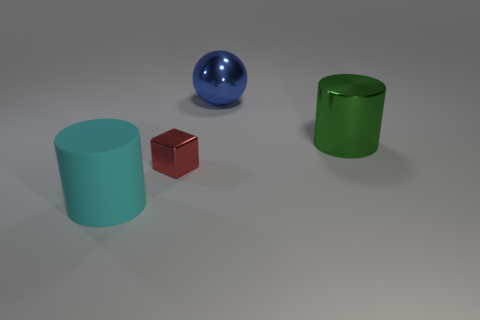Are there any other things that are the same size as the red object?
Provide a succinct answer. No. Is there anything else that has the same material as the cyan object?
Provide a succinct answer. No. There is a cylinder to the left of the metallic cylinder; does it have the same size as the tiny metallic thing?
Your answer should be very brief. No. What number of other objects are there of the same shape as the large blue metal thing?
Provide a succinct answer. 0. Is there a tiny ball that has the same color as the matte thing?
Your answer should be very brief. No. There is a large cyan object; what number of large blue things are behind it?
Ensure brevity in your answer.  1. How many other things are the same size as the cyan rubber cylinder?
Your answer should be very brief. 2. Are the cylinder that is on the right side of the large blue ball and the cylinder that is in front of the big green thing made of the same material?
Give a very brief answer. No. There is another rubber cylinder that is the same size as the green cylinder; what is its color?
Provide a short and direct response. Cyan. What size is the metal thing that is left of the large object that is behind the cylinder that is to the right of the large blue thing?
Your answer should be compact. Small. 